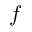<formula> <loc_0><loc_0><loc_500><loc_500>f</formula> 